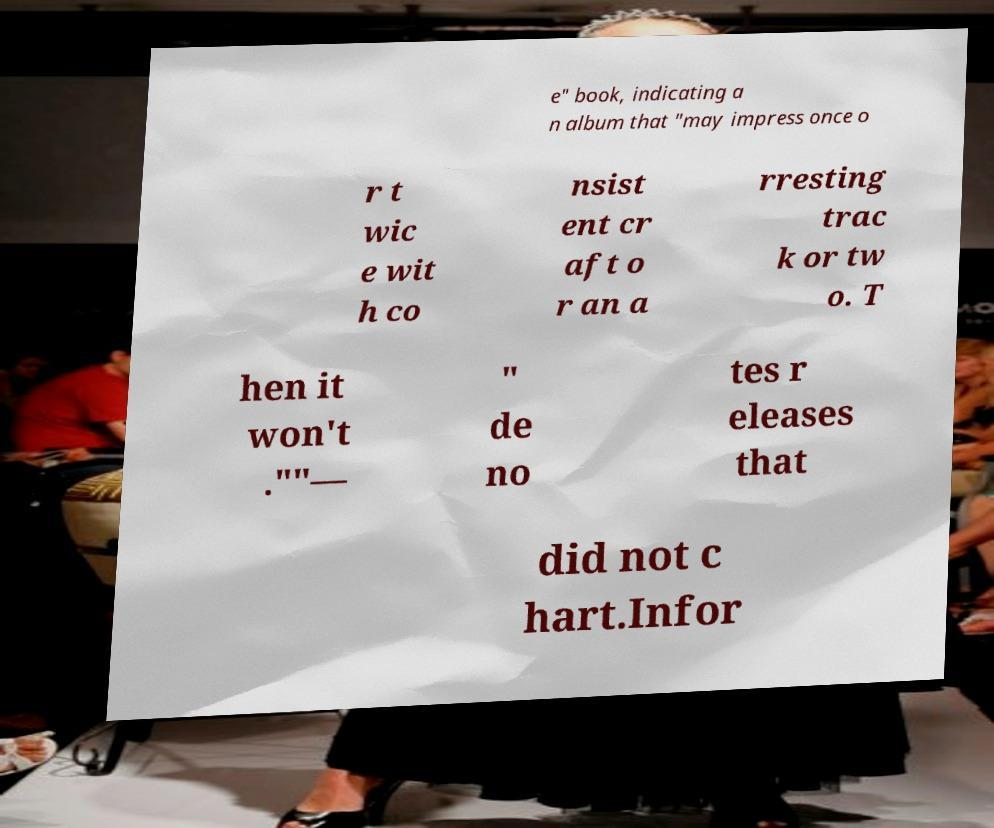Could you assist in decoding the text presented in this image and type it out clearly? e" book, indicating a n album that "may impress once o r t wic e wit h co nsist ent cr aft o r an a rresting trac k or tw o. T hen it won't .""— " de no tes r eleases that did not c hart.Infor 